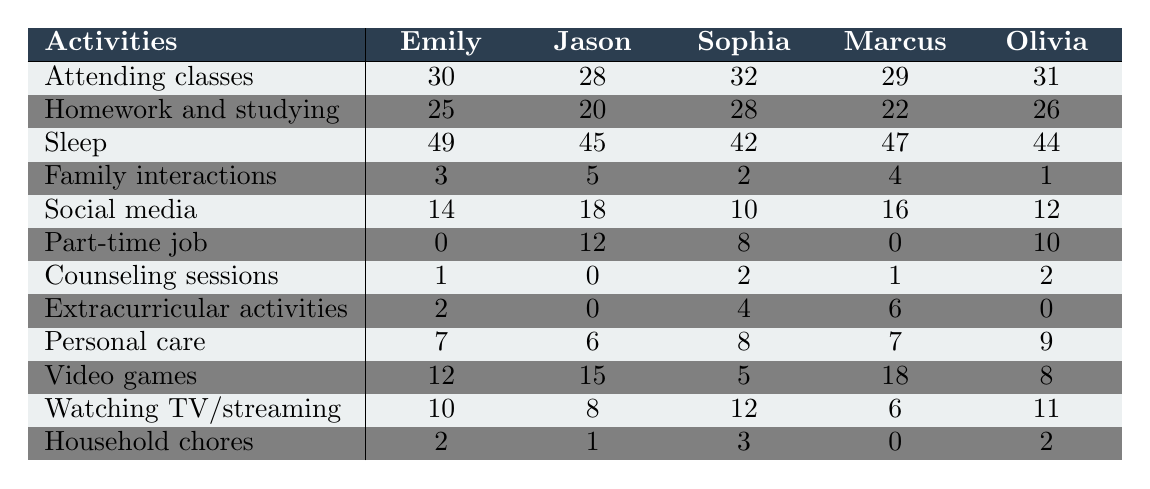What is the maximum number of hours spent on sleeping by a student? The highest value in the 'Sleep' row is 49 hours, which belongs to Emily.
Answer: 49 Which student spends the least time on family interactions? The value for family interactions shows that Olivia spends only 1 hour, which is the lowest compared to the others.
Answer: Olivia How many hours does Marcus spend on video games? The table shows that Marcus spends 18 hours on video games.
Answer: 18 Which activity has the highest total hours across all students? We need to sum the hours for each activity. 'Sleeping' totals 49 + 45 + 42 + 47 + 44 = 227 hours, which is greater than any other activity.
Answer: Sleeping What is the average time spent on homework and studying among all students? To find the average for 'Homework and studying', add all the hours: 25 + 20 + 28 + 22 + 26 = 121. There are 5 students, so the average is 121/5 = 24.2.
Answer: 24.2 Does Jason spend more time on social media than he does attending classes? Jason spends 18 hours on social media and 28 hours attending classes. Since 18 is less than 28, it is false that he spends more time on social media.
Answer: No Who spends more time on extracurricular activities, Sophia or Marcus? Sophia spends 4 hours and Marcus spends 6 hours on extracurricular activities. Since 6 is greater than 4, Marcus spends more time.
Answer: Marcus What is the difference in hours spent on personal care between Emily and Olivia? Emily spends 7 hours and Olivia spends 9 hours. The difference is 9 - 7 = 2 hours.
Answer: 2 Which student has the least overall time allocated for homework and studying and part-time job combined? Add 'Homework and studying' and 'Part-time job' for each student: Emily (25 + 0 = 25), Jason (20 + 12 = 32), Sophia (28 + 8 = 36), Marcus (22 + 0 = 22), Olivia (26 + 10 = 36). Marcus has the least with 22 hours.
Answer: Marcus Are there any students who do not allocate any hours to attending extracurricular activities? Marcus and Sophia both have 0 hours allocated to extracurricular activities, making the statement true.
Answer: Yes 